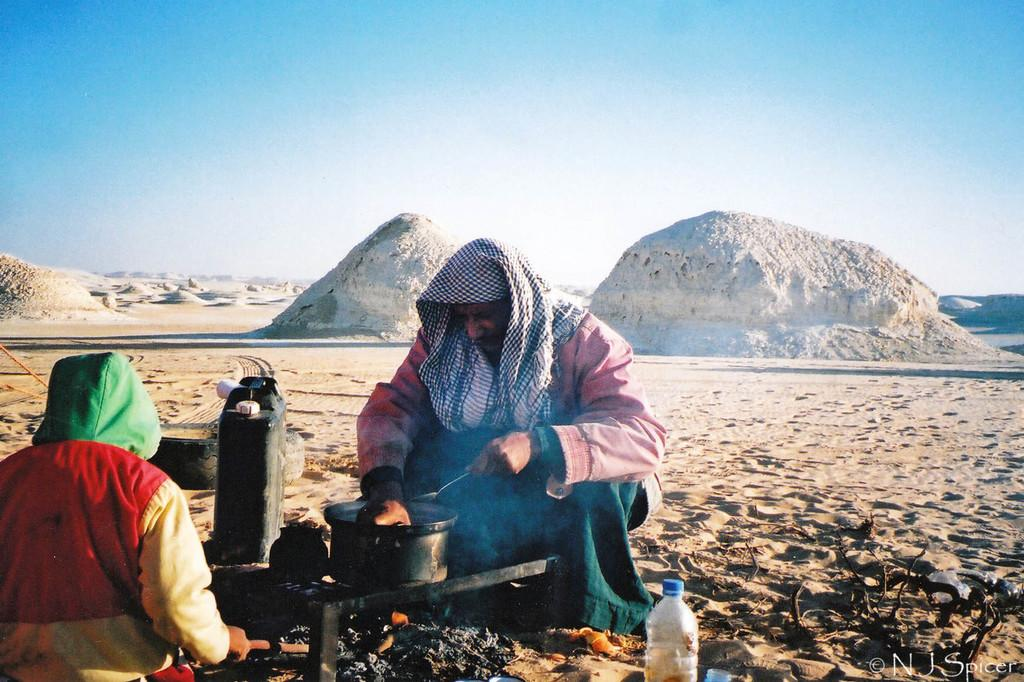How many people are present in the image? There are two people in the image. What types of containers can be seen in the image? There are bottled and water cans in the image. What objects are used for eating in the image? There are spoons in the image. What can be seen in the background of the image? There are mountains, sand, and the sky visible in the background of the image. What type of muscle is being exercised by the people in the image? There is no indication of exercise or muscle activity in the image; the people are simply present. --- Facts: 1. There is a car in the image. 2. The car is red. 3. The car has four wheels. 4. There is a road in the image. 5. The road is paved. 6. There are trees on the side of the road. Absurd Topics: parrot, dance, ocean Conversation: What is the color of the car in the image? The car is red. How many wheels does the car have? The car has four wheels. What type of surface is the road made of? The road is paved. What can be seen on the side of the road? There are trees on the side of the road. Reasoning: Let's think step by step in order to produce the conversation. We start by identifying the main subject in the image, which is the car. Then, we describe the color and number of wheels of the car. Next, we mention the type of surface the road is made of, and finally, we describe the vegetation on the side of the road. Each question is designed to elicit a specific detail about the image that is known from the provided facts. Absurd Question/Answer: Can you tell me how many parrots are sitting on the car in the image? There are no parrots present in the image; the focus is on the car and the road. 